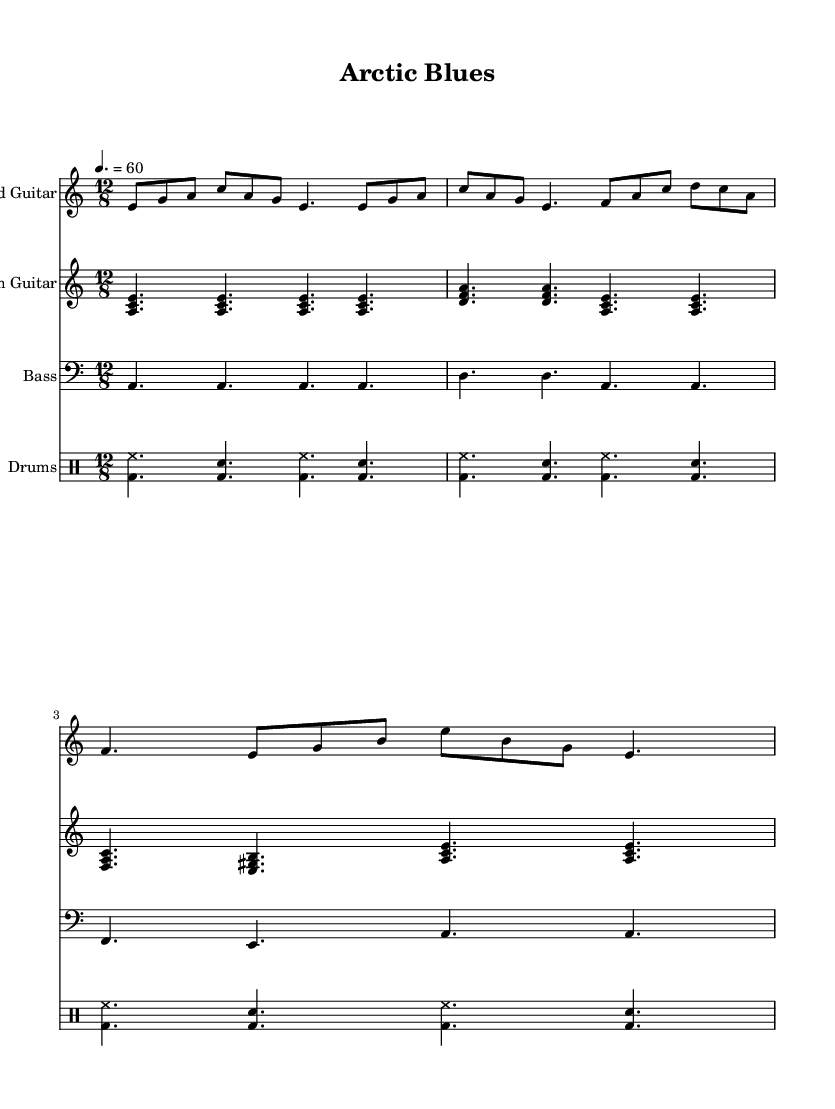What is the key signature of this music? The key signature is A minor, which has no sharps or flats.
Answer: A minor What is the time signature of this music? The time signature is indicated as 12/8, which means there are 12 eighth notes in each measure.
Answer: 12/8 What is the tempo marking for this piece? The tempo marking indicates a speed of 60 beats per minute, which is relatively slow and matches the mournful character of the electric blues.
Answer: 60 How many measures does the lead guitar part have? Counting the measures indicated in the lead guitar part, there are a total of 3 measures.
Answer: 3 measures What are the primary chords used in the rhythm guitar part? The rhythm guitar utilizes the chords A minor, D minor, and F major, as represented in its voicing throughout the measures.
Answer: A minor, D minor, F major What is the dynamic feel of the bass part? The bass part maintains a steady, consistent sound, playing whole notes to establish a strong rhythmic foundation throughout the piece.
Answer: Steady What is the primary mood conveyed by the combination of instruments? The combination of slow tempos, mournful melodies, and steady rhythms creates a feeling of sadness and loss, particularly reflecting themes associated with the melting Arctic.
Answer: Sadness and loss 